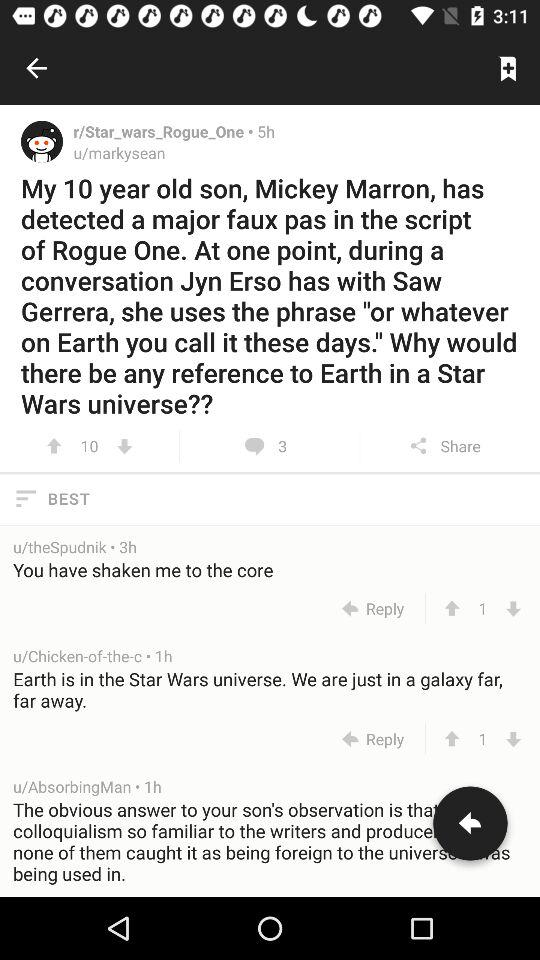How long ago was the article posted by "u/markysean"? The article was posted by "u/markysean" 5 hours ago. 